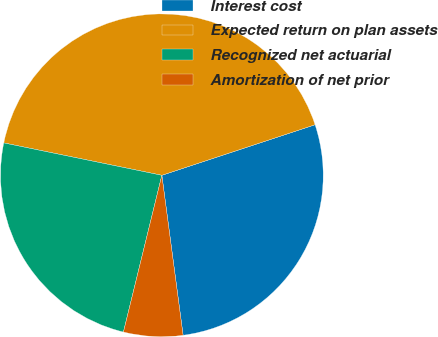Convert chart. <chart><loc_0><loc_0><loc_500><loc_500><pie_chart><fcel>Interest cost<fcel>Expected return on plan assets<fcel>Recognized net actuarial<fcel>Amortization of net prior<nl><fcel>27.97%<fcel>41.71%<fcel>24.39%<fcel>5.93%<nl></chart> 